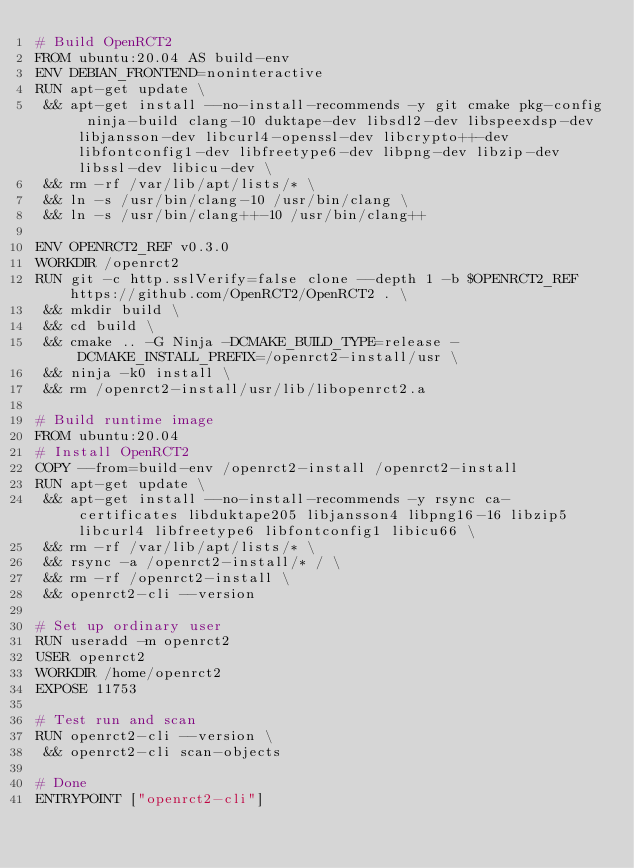Convert code to text. <code><loc_0><loc_0><loc_500><loc_500><_Dockerfile_># Build OpenRCT2
FROM ubuntu:20.04 AS build-env
ENV DEBIAN_FRONTEND=noninteractive
RUN apt-get update \
 && apt-get install --no-install-recommends -y git cmake pkg-config ninja-build clang-10 duktape-dev libsdl2-dev libspeexdsp-dev libjansson-dev libcurl4-openssl-dev libcrypto++-dev libfontconfig1-dev libfreetype6-dev libpng-dev libzip-dev libssl-dev libicu-dev \
 && rm -rf /var/lib/apt/lists/* \
 && ln -s /usr/bin/clang-10 /usr/bin/clang \
 && ln -s /usr/bin/clang++-10 /usr/bin/clang++

ENV OPENRCT2_REF v0.3.0
WORKDIR /openrct2
RUN git -c http.sslVerify=false clone --depth 1 -b $OPENRCT2_REF https://github.com/OpenRCT2/OpenRCT2 . \
 && mkdir build \
 && cd build \
 && cmake .. -G Ninja -DCMAKE_BUILD_TYPE=release -DCMAKE_INSTALL_PREFIX=/openrct2-install/usr \
 && ninja -k0 install \
 && rm /openrct2-install/usr/lib/libopenrct2.a

# Build runtime image
FROM ubuntu:20.04
# Install OpenRCT2
COPY --from=build-env /openrct2-install /openrct2-install
RUN apt-get update \
 && apt-get install --no-install-recommends -y rsync ca-certificates libduktape205 libjansson4 libpng16-16 libzip5 libcurl4 libfreetype6 libfontconfig1 libicu66 \
 && rm -rf /var/lib/apt/lists/* \
 && rsync -a /openrct2-install/* / \
 && rm -rf /openrct2-install \
 && openrct2-cli --version

# Set up ordinary user
RUN useradd -m openrct2
USER openrct2
WORKDIR /home/openrct2
EXPOSE 11753

# Test run and scan
RUN openrct2-cli --version \
 && openrct2-cli scan-objects

# Done
ENTRYPOINT ["openrct2-cli"]
</code> 